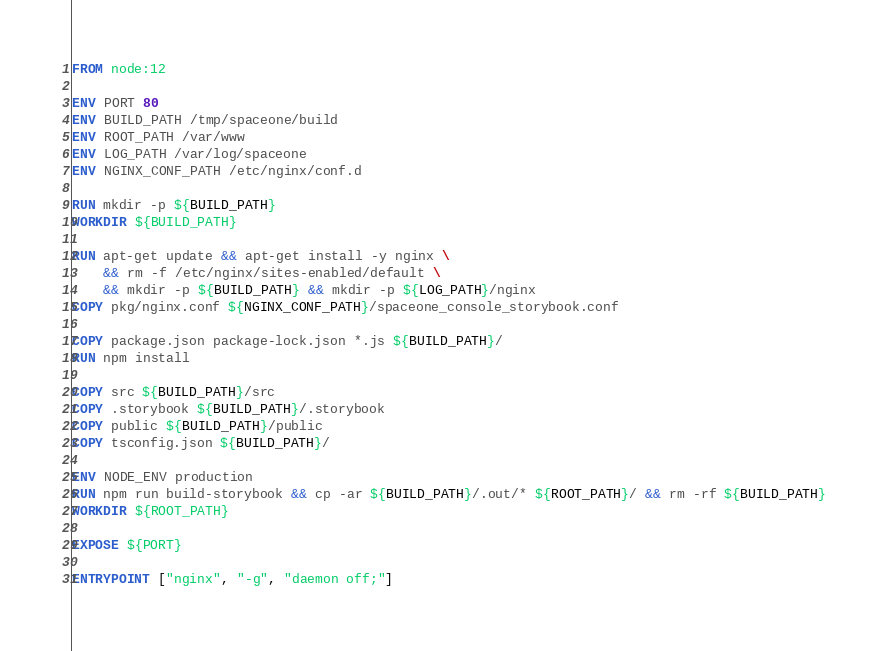Convert code to text. <code><loc_0><loc_0><loc_500><loc_500><_Dockerfile_>FROM node:12

ENV PORT 80
ENV BUILD_PATH /tmp/spaceone/build
ENV ROOT_PATH /var/www
ENV LOG_PATH /var/log/spaceone
ENV NGINX_CONF_PATH /etc/nginx/conf.d

RUN mkdir -p ${BUILD_PATH}
WORKDIR ${BUILD_PATH}

RUN apt-get update && apt-get install -y nginx \
    && rm -f /etc/nginx/sites-enabled/default \
    && mkdir -p ${BUILD_PATH} && mkdir -p ${LOG_PATH}/nginx
COPY pkg/nginx.conf ${NGINX_CONF_PATH}/spaceone_console_storybook.conf

COPY package.json package-lock.json *.js ${BUILD_PATH}/
RUN npm install

COPY src ${BUILD_PATH}/src
COPY .storybook ${BUILD_PATH}/.storybook
COPY public ${BUILD_PATH}/public
COPY tsconfig.json ${BUILD_PATH}/

ENV NODE_ENV production
RUN npm run build-storybook && cp -ar ${BUILD_PATH}/.out/* ${ROOT_PATH}/ && rm -rf ${BUILD_PATH}
WORKDIR ${ROOT_PATH}

EXPOSE ${PORT}

ENTRYPOINT ["nginx", "-g", "daemon off;"]
</code> 